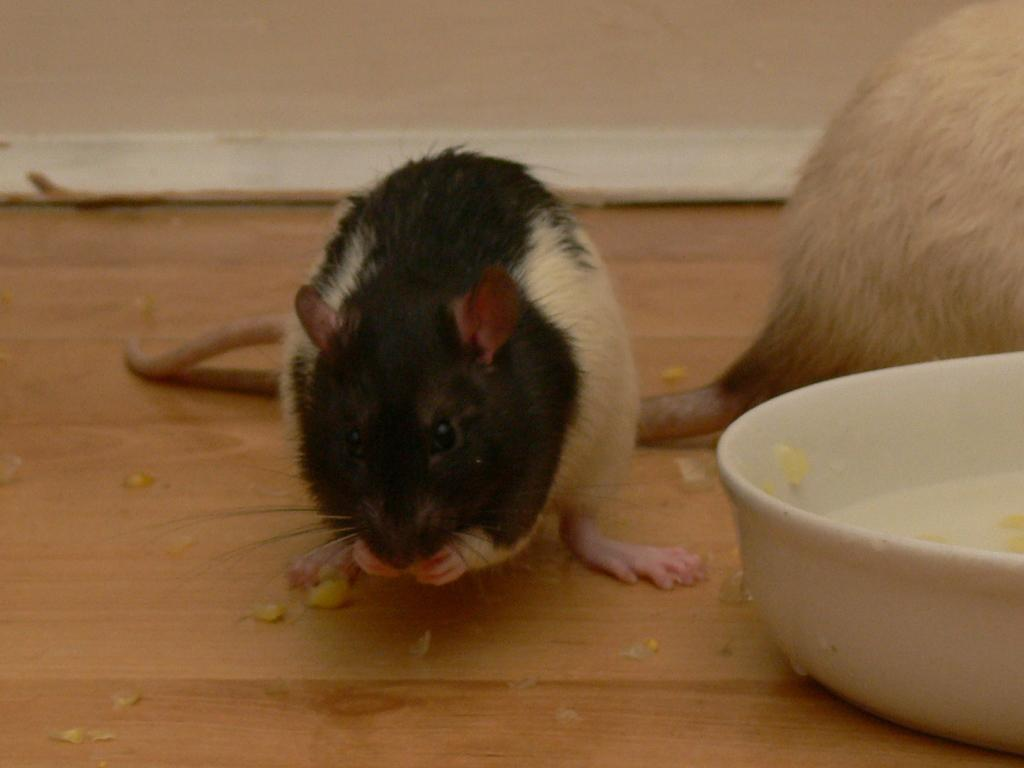What animals are present on the wooden surface in the image? There are rats on the wooden surface. What object can be seen on the wooden surface besides the rats? There is a bowl on the wooden surface. What things are being tested in the image? There are no things being tested in the image; it features rats on a wooden surface and a bowl. What type of crib is visible in the image? There is no crib present in the image. 